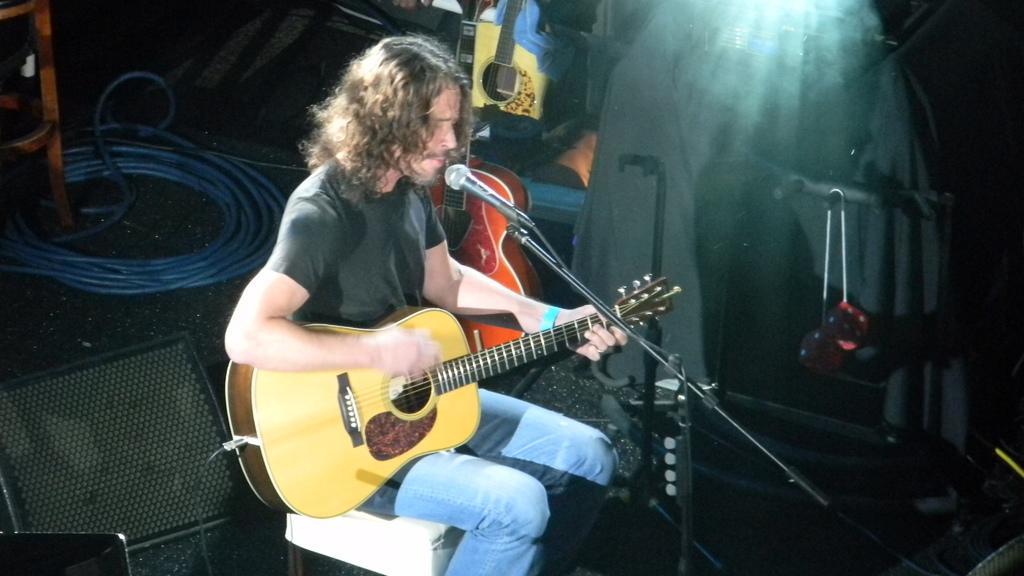Describe this image in one or two sentences. In the picture we can see a man sitting on the chair and holding a guitar, playing it before the microphone, background we can see wires, chair, another guitar and a curtain which is covered some things. 